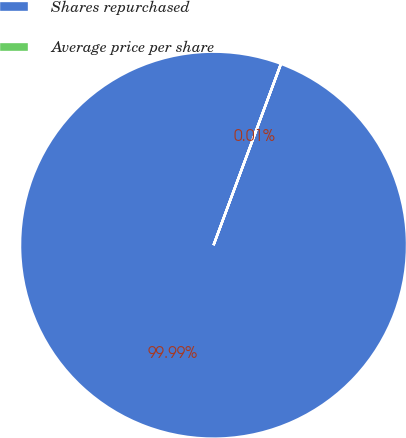Convert chart. <chart><loc_0><loc_0><loc_500><loc_500><pie_chart><fcel>Shares repurchased<fcel>Average price per share<nl><fcel>99.99%<fcel>0.01%<nl></chart> 